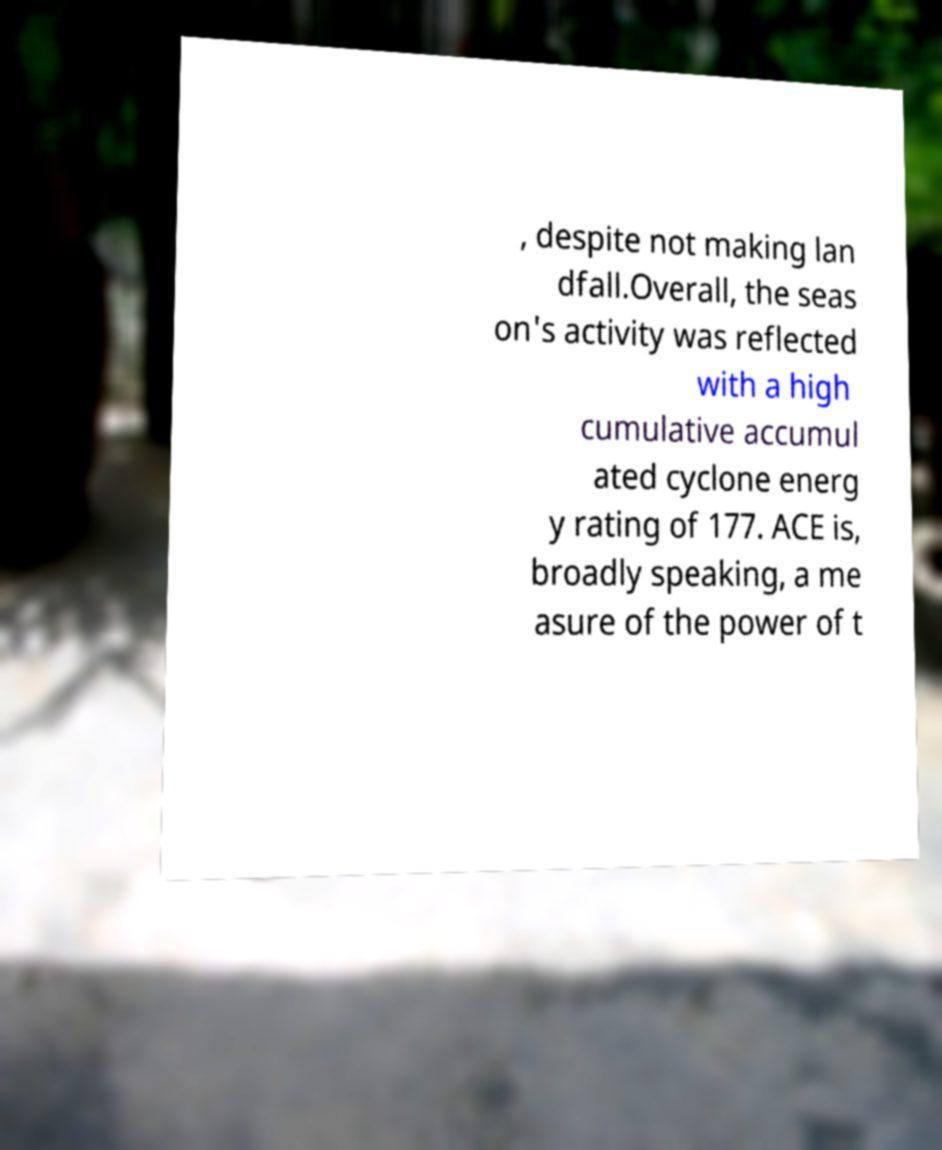Can you read and provide the text displayed in the image?This photo seems to have some interesting text. Can you extract and type it out for me? , despite not making lan dfall.Overall, the seas on's activity was reflected with a high cumulative accumul ated cyclone energ y rating of 177. ACE is, broadly speaking, a me asure of the power of t 